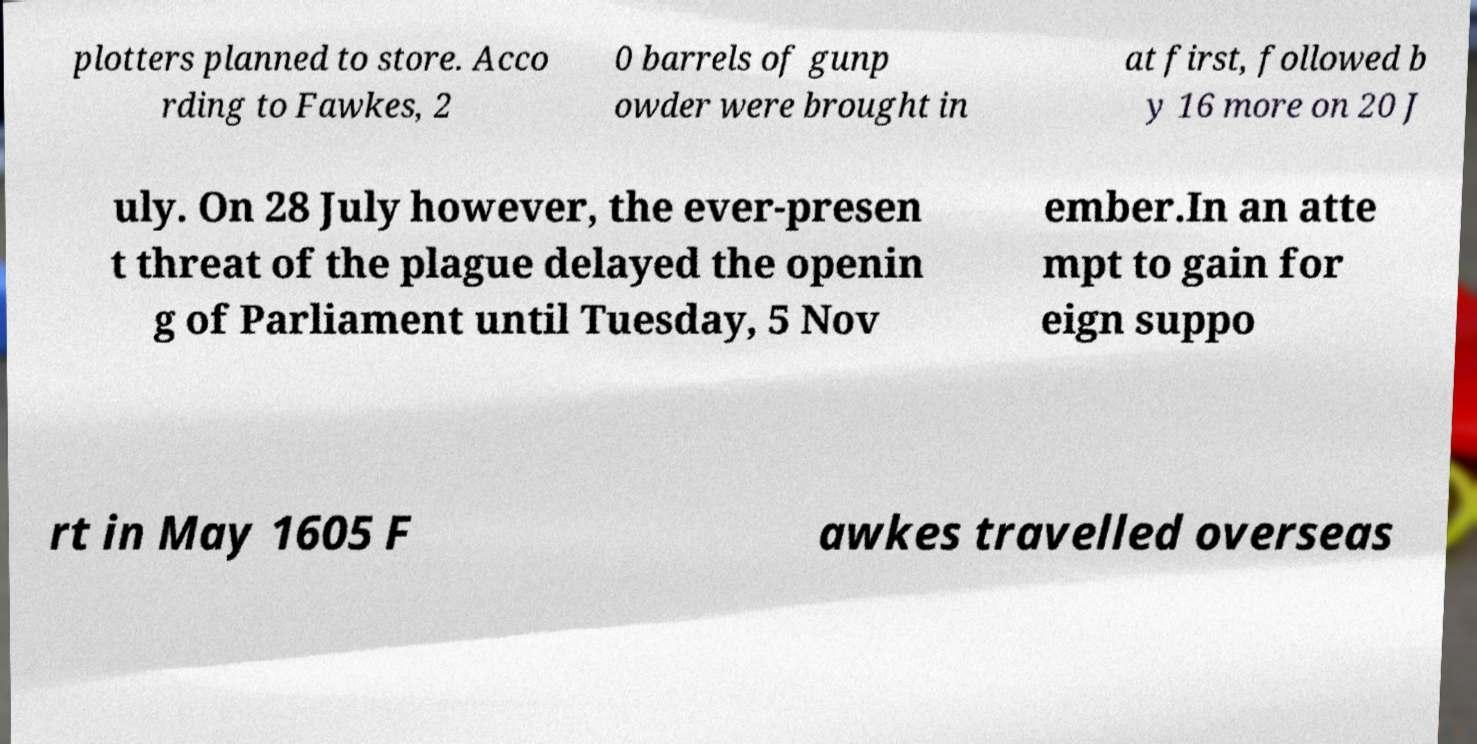Can you accurately transcribe the text from the provided image for me? plotters planned to store. Acco rding to Fawkes, 2 0 barrels of gunp owder were brought in at first, followed b y 16 more on 20 J uly. On 28 July however, the ever-presen t threat of the plague delayed the openin g of Parliament until Tuesday, 5 Nov ember.In an atte mpt to gain for eign suppo rt in May 1605 F awkes travelled overseas 